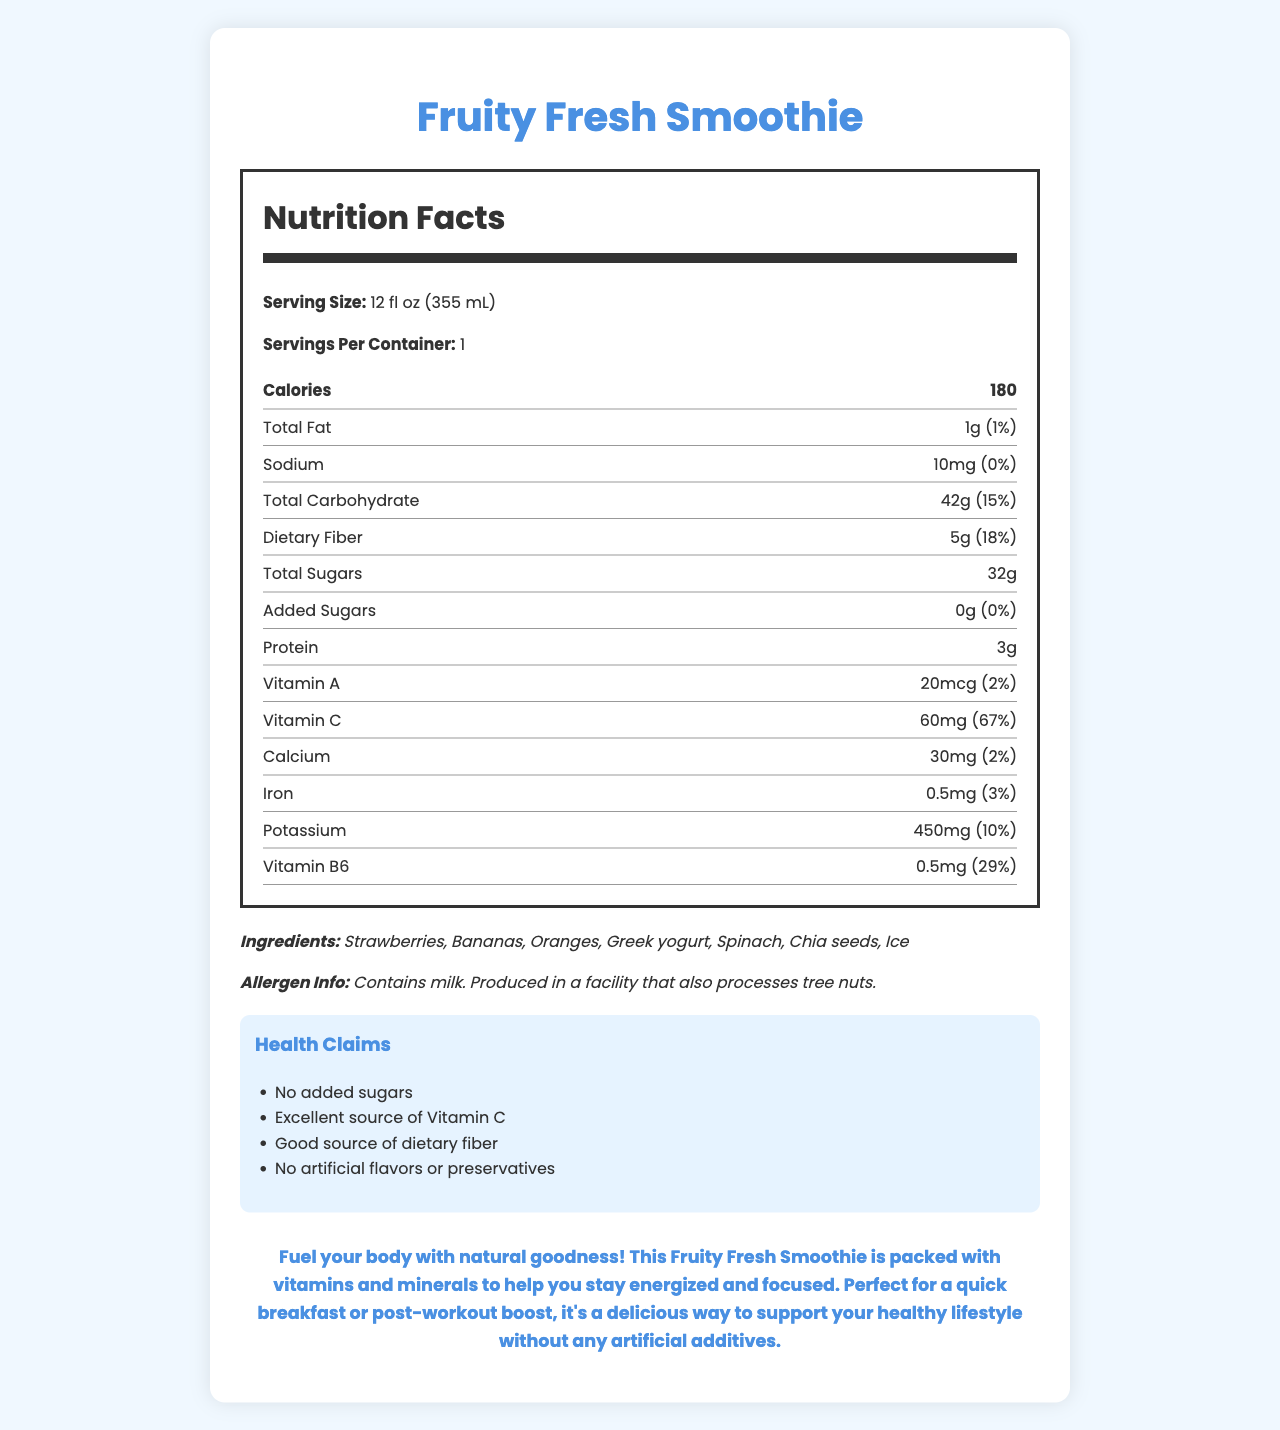what is the serving size? The document specifies that the serving size of the Fruity Fresh Smoothie is 12 fl oz (355 mL).
Answer: 12 fl oz (355 mL) how many calories are in one serving? The document states that there are 180 calories in one serving of the Fruity Fresh Smoothie.
Answer: 180 how much dietary fiber is in the smoothie? The nutrition facts indicate that the smoothie contains 5 grams of dietary fiber.
Answer: 5g which vitamin has the highest daily value percentage? According to the document, Vitamin C has a daily value percentage of 67%.
Answer: Vitamin C does this smoothie contain any added sugars? The document specifies that the smoothie contains 0 grams of added sugars.
Answer: No how much protein does the Fruity Fresh Smoothie have? The nutrition facts section lists that the smoothie contains 3 grams of protein.
Answer: 3g which of the following is not an ingredient in the smoothie? A. Bananas B. Ice C. Almonds D. Spinach The list of ingredients includes bananas, ice, and spinach but does not include almonds.
Answer: C. Almonds what is the main source of calcium in the Fruity Fresh Smoothie? A. Strawberries B. Greek yogurt C. Chia seeds D. Oranges Greek yogurt is typically a significant source of calcium and is listed among the ingredients.
Answer: B. Greek yogurt does the smoothie contain any artificial flavors? One of the health claims is that the smoothie contains no artificial flavors or preservatives.
Answer: No can I consume this smoothie if I have a tree nut allergy? The allergen info states that the product is produced in a facility that processes tree nuts, making it risky for those with tree nut allergies.
Answer: No summarize the main idea of the document. The document provides detailed nutritional information about the Fruity Fresh Smoothie, listing calorie content, vitamins, and ingredients while emphasizing its health benefits and natural ingredients without additives.
Answer: The Fruity Fresh Smoothie is a healthy beverage option made with natural ingredients, providing essential vitamins and minerals like Vitamin C and dietary fiber. It has no added sugars or artificial flavors and is described as a great choice for a quick breakfast or post-workout boost. However, it contains milk and may be produced in a facility that processes tree nuts. describe the allergen information provided. The allergen information specifies that the smoothie contains milk and is produced in a facility that processes tree nuts, which is important for individuals with these allergies.
Answer: Contains milk. Produced in a facility that also processes tree nuts. what is the daily value of total carbohydrates in the smoothie? The document mentions that the total carbohydrate daily value is 15%.
Answer: 15% how much potassium does the smoothie contain? According to the nutrition facts, the smoothie contains 450 milligrams of potassium.
Answer: 450mg what is the fruity fresh smoothie described as in the teen-friendly section? The teen-friendly description emphasizes the smoothie’s natural ingredients, health benefits, and suitability for a healthy lifestyle.
Answer: Fuel your body with natural goodness! This Fruity Fresh Smoothie is packed with vitamins and minerals to help you stay energized and focused. Perfect for a quick breakfast or post-workout boost, it's a delicious way to support your healthy lifestyle without any artificial additives. how many servings are in one container? The document states that there is one serving per container of the Fruity Fresh Smoothie.
Answer: 1 is the amount of iron in the smoothie considered high? The daily value of iron is only 3%, which is relatively low and not considered high.
Answer: No what type of facility is the smoothie produced in? The document specifies that the smoothie is produced in a facility that processes tree nuts, which is part of the allergen information.
Answer: Produced in a facility that also processes tree nuts. is the total fat content significant? The total fat content is only 1 gram, which contributes to 1% of the daily value, indicating it is not significant.
Answer: No how many different vitamins and minerals are listed on the nutrition facts label? The nutrition facts label lists six vitamins and minerals: Vitamin A, Vitamin C, Calcium, Iron, Potassium, and Vitamin B6.
Answer: 6 does the smoothie contain organic ingredients? The document does not indicate whether the ingredients are organic.
Answer: Not enough information 